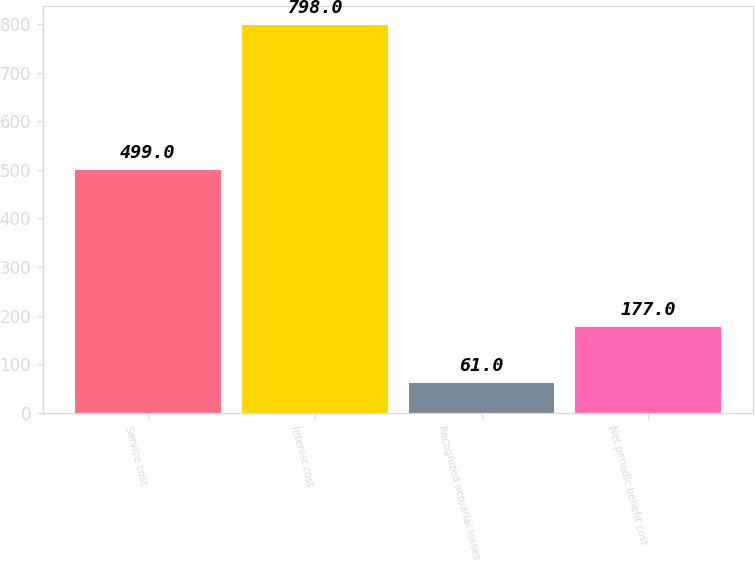Convert chart to OTSL. <chart><loc_0><loc_0><loc_500><loc_500><bar_chart><fcel>Service cost<fcel>Interest cost<fcel>Recognized actuarial losses<fcel>Net periodic benefit cost<nl><fcel>499<fcel>798<fcel>61<fcel>177<nl></chart> 